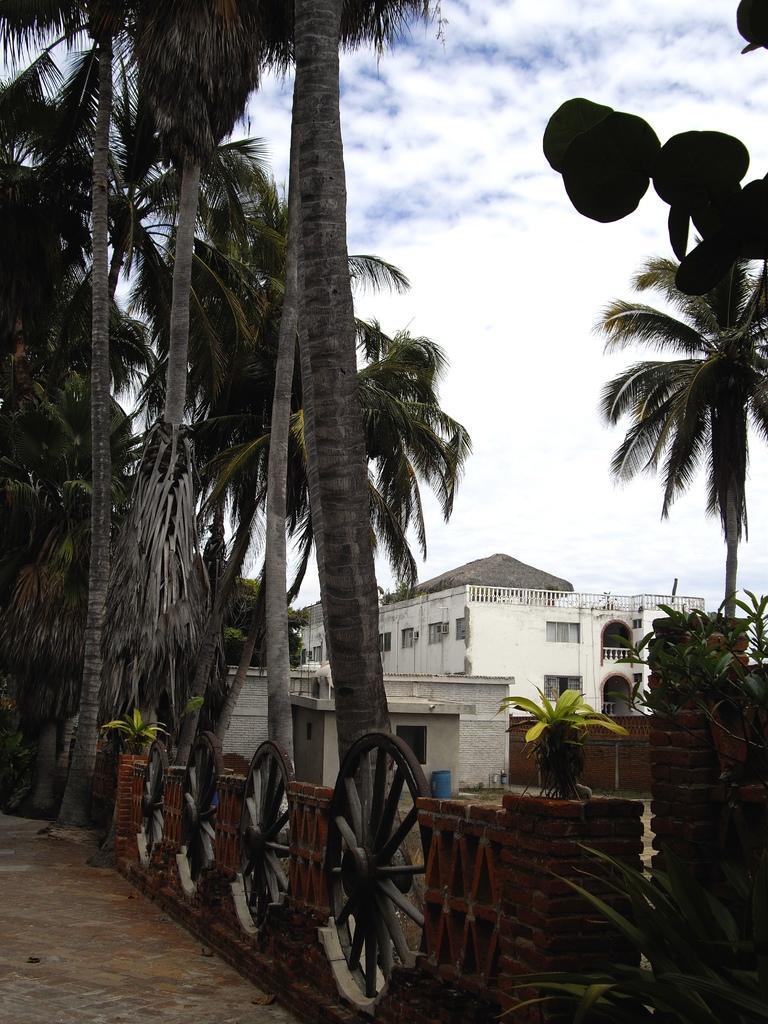In one or two sentences, can you explain what this image depicts? In this picture we can see the sky, building, houses, trees, plants and a barrel. We can see the wheels. 